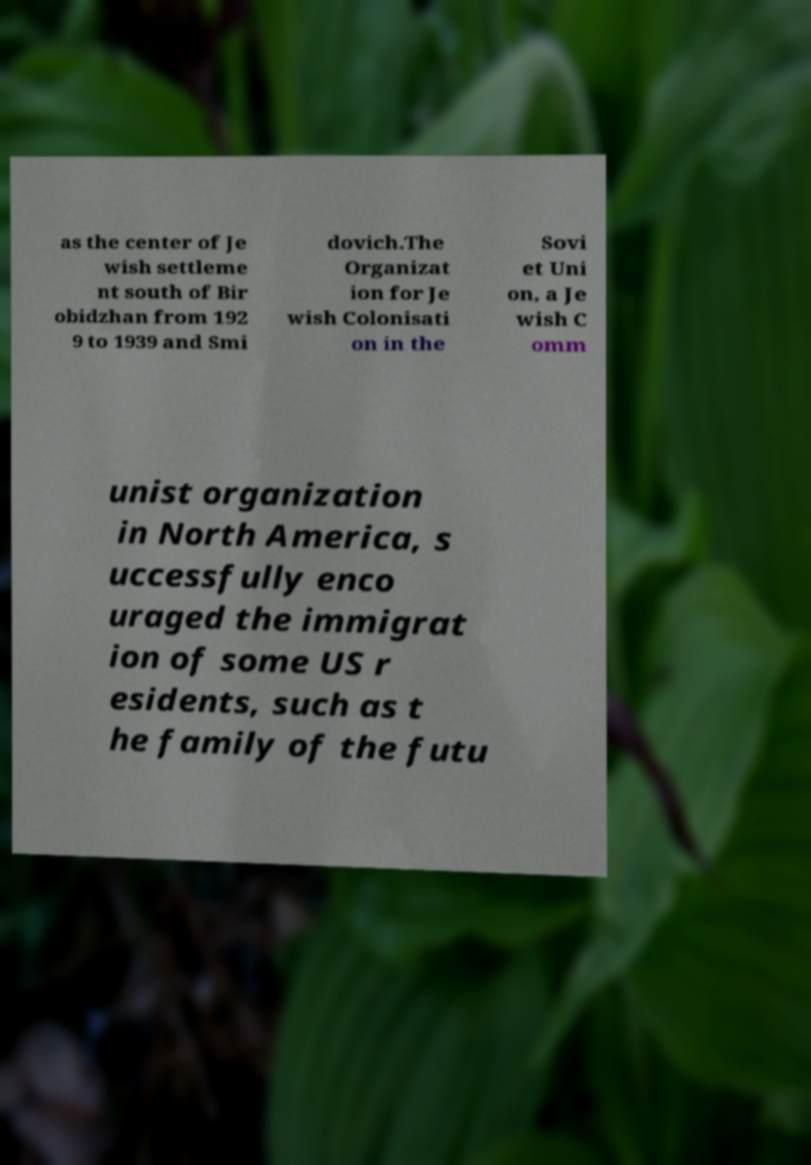Please read and relay the text visible in this image. What does it say? as the center of Je wish settleme nt south of Bir obidzhan from 192 9 to 1939 and Smi dovich.The Organizat ion for Je wish Colonisati on in the Sovi et Uni on, a Je wish C omm unist organization in North America, s uccessfully enco uraged the immigrat ion of some US r esidents, such as t he family of the futu 